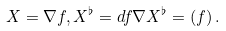<formula> <loc_0><loc_0><loc_500><loc_500>X = \nabla f , X ^ { \flat } = d f \nabla X ^ { \flat } = ( f ) \, .</formula> 